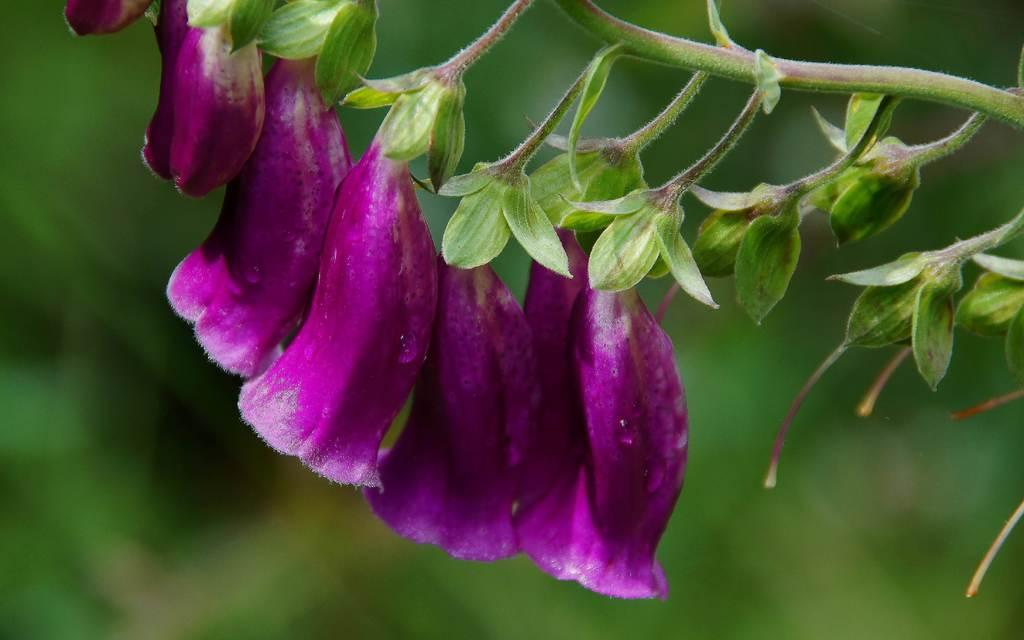What type of flowers can be seen in the image? There are violet flowers in the image. Are the flowers part of a larger plant? Yes, the flowers are part of a plant. How is the background of the flowers depicted in the image? The background of the flowers is blurred. Can you hear the thunder in the background of the image? There is no mention of thunder or any sound in the image, so it cannot be heard. 